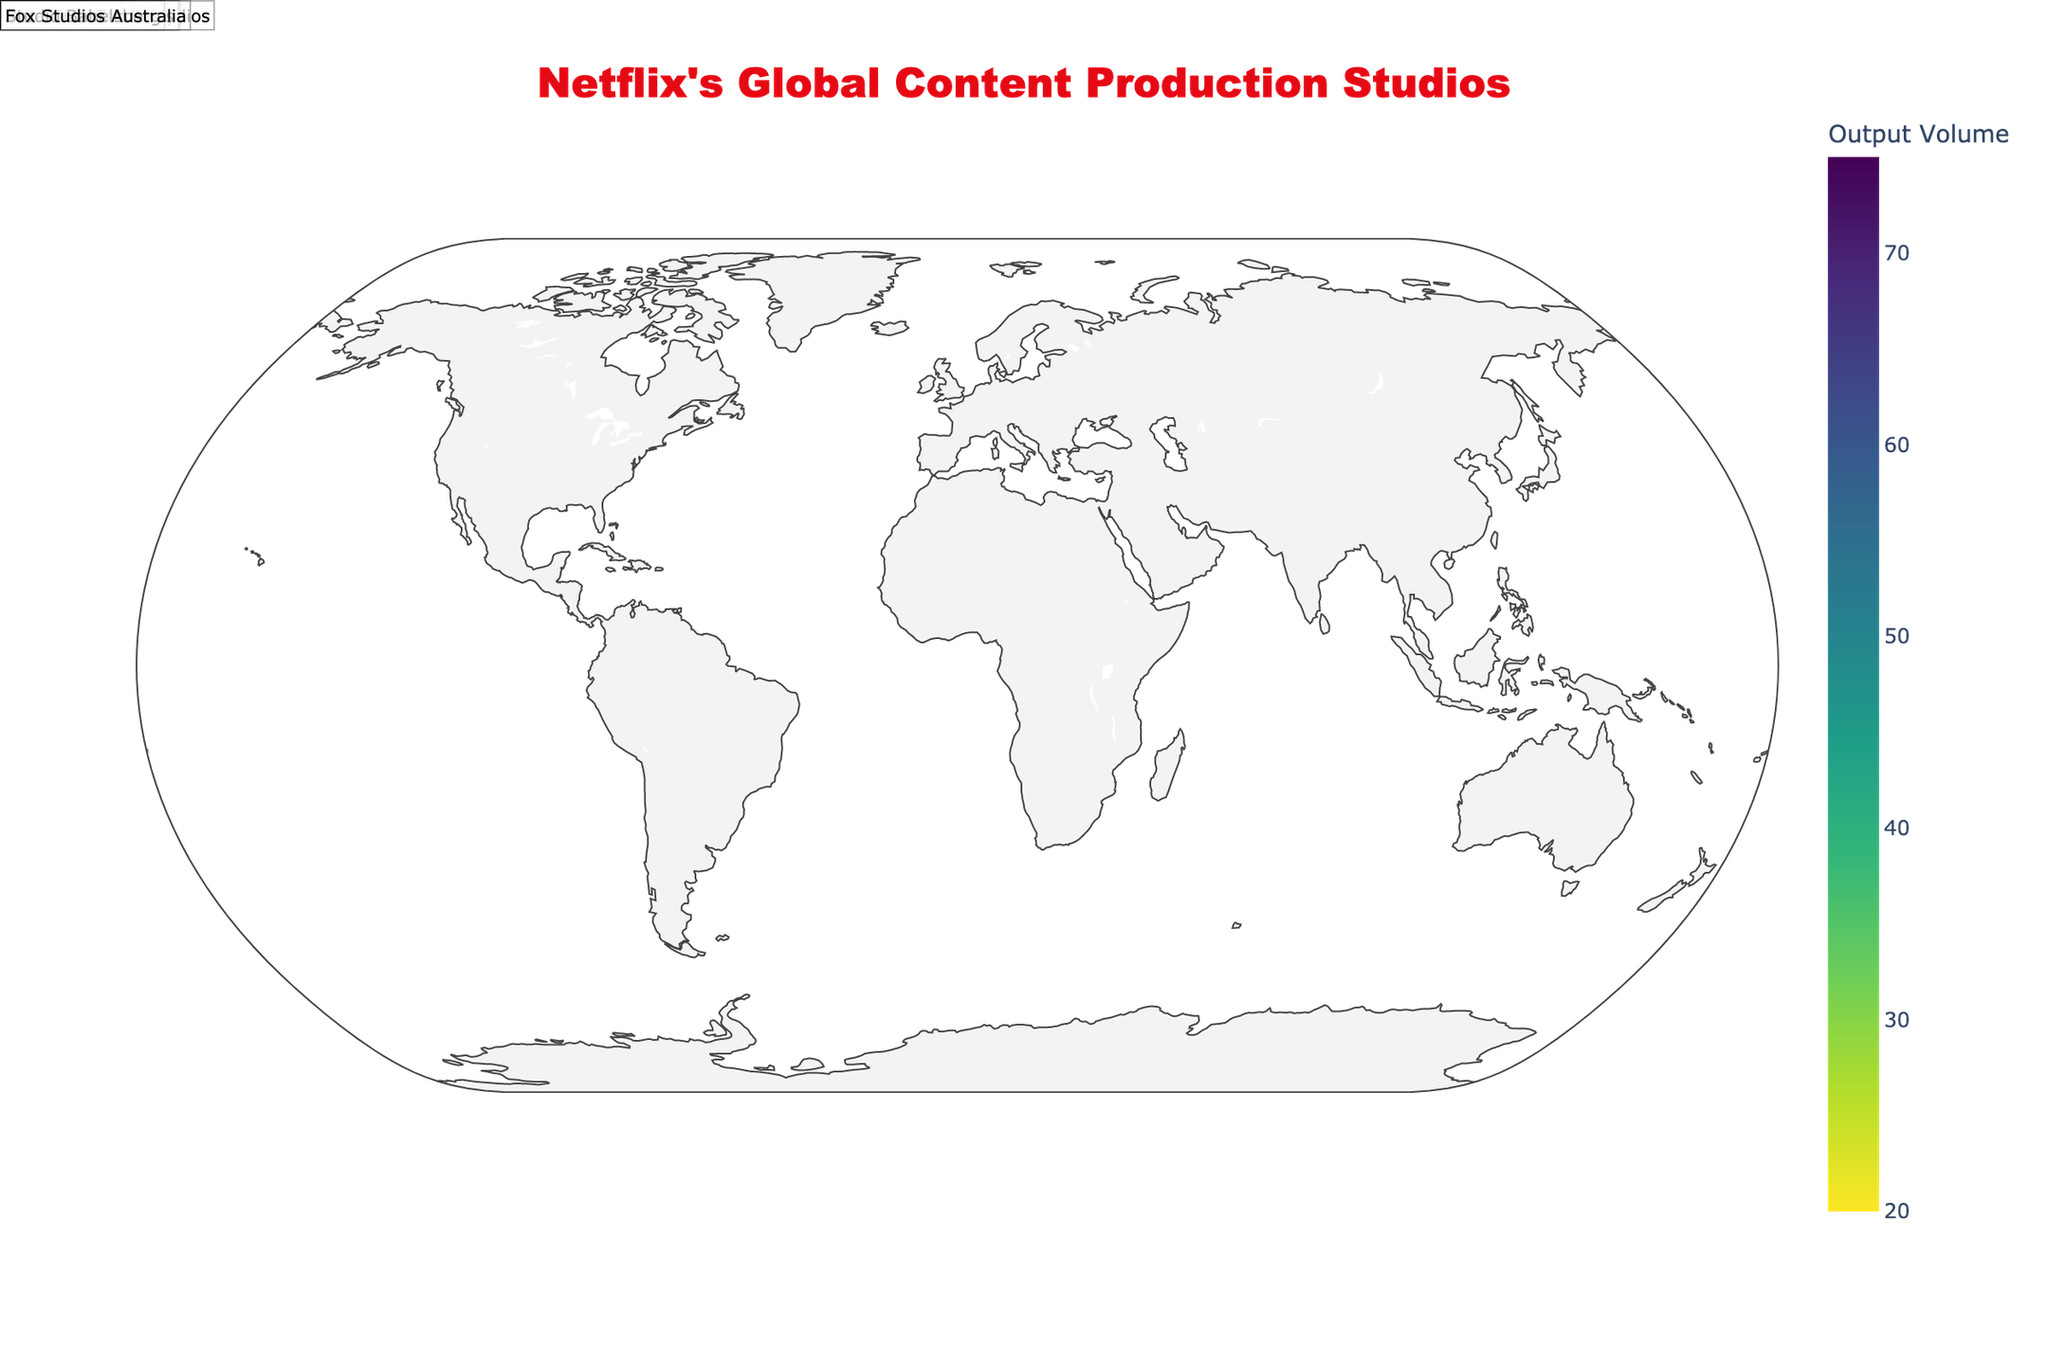Which studio has the highest output volume? The plot shows the output volume of each studio as circle sizes and also color-coded. The studio with the largest circle and the most intense color indicates the highest output volume.
Answer: Sunset Bronson Studios What is the title of the plot? The plot's title is shown prominently at the top center.
Answer: Netflix's Global Content Production Studios Which studio produced the soundtrack for Dark? Hovering over the data points in the plot shows additional information, including the top show soundtrack produced by each studio. Look for the entry for "Dark" to find the corresponding studio.
Answer: Studio Babelsberg How many studios are represented in the plot? Each data point represents a studio. Count the number of data points in the plot.
Answer: 10 What is the combined output volume of studios in Europe? Identify the studios located in European countries (Madrid Content City, Shepperton Studios, and Studio Babelsberg), then sum their output volumes: 60 + 50 + 55
Answer: 165 Which studio has a lower output volume, Fox Studios Australia or Vera Cruz Studios? Compare the output volume of Fox Studios Australia and Vera Cruz Studios as shown by the circle size and the hover information.
Answer: Fox Studios Australia What is the output volume difference between the studios in Los Angeles, USA, and Tokyo, Japan? The output volume for Sunset Bronson Studios in Los Angeles is 75, and for Toho Studios in Tokyo is 30. Calculate the difference: 75 - 30
Answer: 45 Which studio is closest in output volume to Madrid Content City? Madrid Content City's output volume is 60. Look for studios with output volumes close to 60 and identify the closest one.
Answer: Shepperton Studios What is the average output volume of all studios? Sum the output volumes of all studios and divide by the number of studios to find the average. (75 + 45 + 60 + 50 + 30 + 40 + 35 + 25 + 55 + 20) / 10
Answer: 43.5 